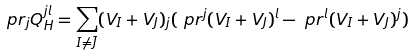Convert formula to latex. <formula><loc_0><loc_0><loc_500><loc_500>\ p r _ { j } Q _ { H } ^ { j l } & = \sum _ { I \neq \bar { J } } ( V _ { I } + V _ { J } ) _ { j } ( \ p r ^ { j } ( V _ { I } + V _ { J } ) ^ { l } - \ p r ^ { l } ( V _ { I } + V _ { J } ) ^ { j } )</formula> 